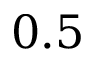<formula> <loc_0><loc_0><loc_500><loc_500>0 . 5</formula> 